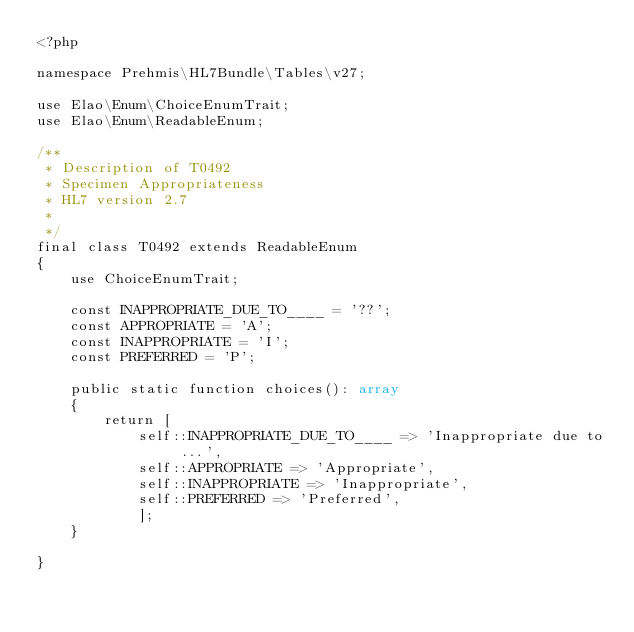<code> <loc_0><loc_0><loc_500><loc_500><_PHP_><?php
    
namespace Prehmis\HL7Bundle\Tables\v27;

use Elao\Enum\ChoiceEnumTrait;
use Elao\Enum\ReadableEnum;

/**
 * Description of T0492
 * Specimen Appropriateness
 * HL7 version 2.7
 *
 */
final class T0492 extends ReadableEnum
{
    use ChoiceEnumTrait;

    const INAPPROPRIATE_DUE_TO____ = '??';
    const APPROPRIATE = 'A';
    const INAPPROPRIATE = 'I';
    const PREFERRED = 'P';
            
    public static function choices(): array
    {
        return [
            self::INAPPROPRIATE_DUE_TO____ => 'Inappropriate due to ...',
            self::APPROPRIATE => 'Appropriate',
            self::INAPPROPRIATE => 'Inappropriate',
            self::PREFERRED => 'Preferred',
            ];
    }
      
}</code> 